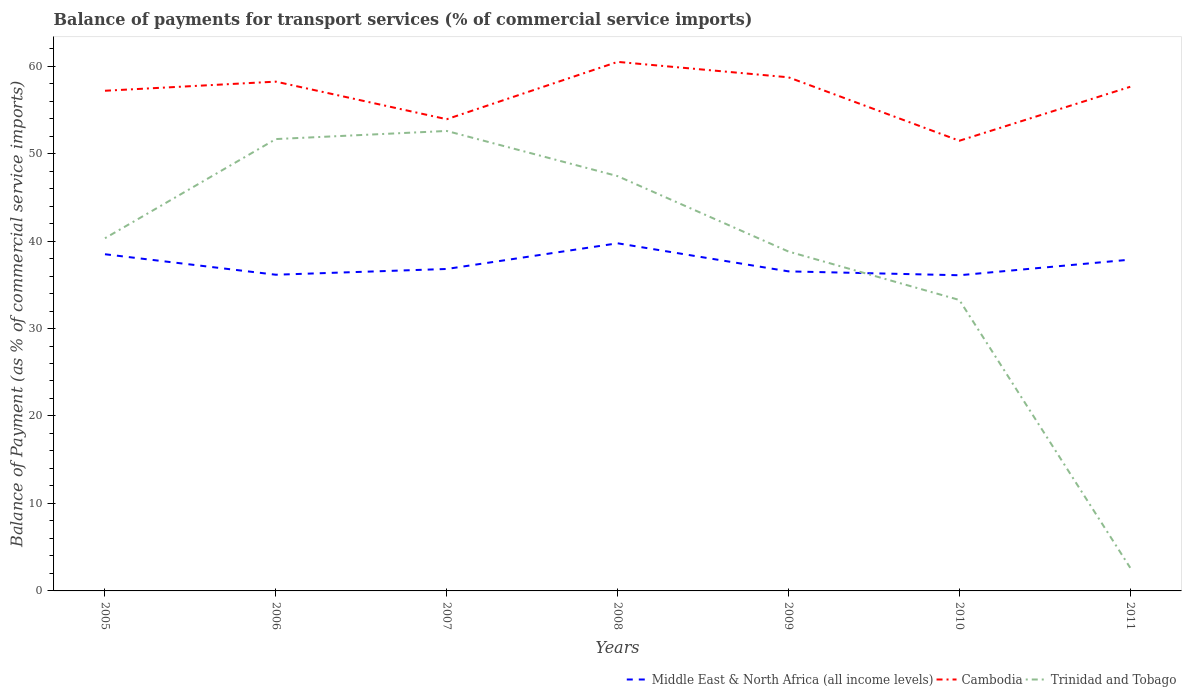How many different coloured lines are there?
Ensure brevity in your answer.  3. Does the line corresponding to Cambodia intersect with the line corresponding to Middle East & North Africa (all income levels)?
Provide a short and direct response. No. Across all years, what is the maximum balance of payments for transport services in Cambodia?
Ensure brevity in your answer.  51.47. In which year was the balance of payments for transport services in Trinidad and Tobago maximum?
Offer a terse response. 2011. What is the total balance of payments for transport services in Cambodia in the graph?
Give a very brief answer. -2.26. What is the difference between the highest and the second highest balance of payments for transport services in Middle East & North Africa (all income levels)?
Keep it short and to the point. 3.65. What is the difference between the highest and the lowest balance of payments for transport services in Cambodia?
Your response must be concise. 5. Is the balance of payments for transport services in Trinidad and Tobago strictly greater than the balance of payments for transport services in Middle East & North Africa (all income levels) over the years?
Offer a very short reply. No. How many lines are there?
Provide a succinct answer. 3. What is the difference between two consecutive major ticks on the Y-axis?
Provide a short and direct response. 10. Does the graph contain any zero values?
Provide a succinct answer. No. Does the graph contain grids?
Keep it short and to the point. No. Where does the legend appear in the graph?
Ensure brevity in your answer.  Bottom right. How many legend labels are there?
Provide a short and direct response. 3. What is the title of the graph?
Ensure brevity in your answer.  Balance of payments for transport services (% of commercial service imports). Does "Togo" appear as one of the legend labels in the graph?
Make the answer very short. No. What is the label or title of the Y-axis?
Offer a terse response. Balance of Payment (as % of commercial service imports). What is the Balance of Payment (as % of commercial service imports) in Middle East & North Africa (all income levels) in 2005?
Give a very brief answer. 38.49. What is the Balance of Payment (as % of commercial service imports) in Cambodia in 2005?
Provide a succinct answer. 57.18. What is the Balance of Payment (as % of commercial service imports) of Trinidad and Tobago in 2005?
Ensure brevity in your answer.  40.32. What is the Balance of Payment (as % of commercial service imports) of Middle East & North Africa (all income levels) in 2006?
Offer a very short reply. 36.15. What is the Balance of Payment (as % of commercial service imports) in Cambodia in 2006?
Make the answer very short. 58.22. What is the Balance of Payment (as % of commercial service imports) of Trinidad and Tobago in 2006?
Give a very brief answer. 51.66. What is the Balance of Payment (as % of commercial service imports) of Middle East & North Africa (all income levels) in 2007?
Your answer should be compact. 36.81. What is the Balance of Payment (as % of commercial service imports) of Cambodia in 2007?
Your answer should be compact. 53.93. What is the Balance of Payment (as % of commercial service imports) of Trinidad and Tobago in 2007?
Give a very brief answer. 52.58. What is the Balance of Payment (as % of commercial service imports) of Middle East & North Africa (all income levels) in 2008?
Your answer should be very brief. 39.74. What is the Balance of Payment (as % of commercial service imports) in Cambodia in 2008?
Keep it short and to the point. 60.48. What is the Balance of Payment (as % of commercial service imports) of Trinidad and Tobago in 2008?
Ensure brevity in your answer.  47.42. What is the Balance of Payment (as % of commercial service imports) of Middle East & North Africa (all income levels) in 2009?
Ensure brevity in your answer.  36.53. What is the Balance of Payment (as % of commercial service imports) in Cambodia in 2009?
Offer a terse response. 58.72. What is the Balance of Payment (as % of commercial service imports) of Trinidad and Tobago in 2009?
Keep it short and to the point. 38.8. What is the Balance of Payment (as % of commercial service imports) in Middle East & North Africa (all income levels) in 2010?
Offer a terse response. 36.09. What is the Balance of Payment (as % of commercial service imports) of Cambodia in 2010?
Your answer should be compact. 51.47. What is the Balance of Payment (as % of commercial service imports) of Trinidad and Tobago in 2010?
Your response must be concise. 33.26. What is the Balance of Payment (as % of commercial service imports) of Middle East & North Africa (all income levels) in 2011?
Your answer should be very brief. 37.87. What is the Balance of Payment (as % of commercial service imports) in Cambodia in 2011?
Offer a very short reply. 57.63. What is the Balance of Payment (as % of commercial service imports) in Trinidad and Tobago in 2011?
Offer a very short reply. 2.64. Across all years, what is the maximum Balance of Payment (as % of commercial service imports) in Middle East & North Africa (all income levels)?
Keep it short and to the point. 39.74. Across all years, what is the maximum Balance of Payment (as % of commercial service imports) in Cambodia?
Provide a short and direct response. 60.48. Across all years, what is the maximum Balance of Payment (as % of commercial service imports) of Trinidad and Tobago?
Offer a terse response. 52.58. Across all years, what is the minimum Balance of Payment (as % of commercial service imports) in Middle East & North Africa (all income levels)?
Offer a terse response. 36.09. Across all years, what is the minimum Balance of Payment (as % of commercial service imports) of Cambodia?
Your answer should be compact. 51.47. Across all years, what is the minimum Balance of Payment (as % of commercial service imports) of Trinidad and Tobago?
Your answer should be very brief. 2.64. What is the total Balance of Payment (as % of commercial service imports) in Middle East & North Africa (all income levels) in the graph?
Provide a short and direct response. 261.68. What is the total Balance of Payment (as % of commercial service imports) in Cambodia in the graph?
Give a very brief answer. 397.63. What is the total Balance of Payment (as % of commercial service imports) in Trinidad and Tobago in the graph?
Your response must be concise. 266.69. What is the difference between the Balance of Payment (as % of commercial service imports) in Middle East & North Africa (all income levels) in 2005 and that in 2006?
Offer a terse response. 2.34. What is the difference between the Balance of Payment (as % of commercial service imports) of Cambodia in 2005 and that in 2006?
Your response must be concise. -1.04. What is the difference between the Balance of Payment (as % of commercial service imports) in Trinidad and Tobago in 2005 and that in 2006?
Your answer should be very brief. -11.34. What is the difference between the Balance of Payment (as % of commercial service imports) in Middle East & North Africa (all income levels) in 2005 and that in 2007?
Keep it short and to the point. 1.68. What is the difference between the Balance of Payment (as % of commercial service imports) in Cambodia in 2005 and that in 2007?
Provide a short and direct response. 3.25. What is the difference between the Balance of Payment (as % of commercial service imports) of Trinidad and Tobago in 2005 and that in 2007?
Offer a very short reply. -12.26. What is the difference between the Balance of Payment (as % of commercial service imports) in Middle East & North Africa (all income levels) in 2005 and that in 2008?
Give a very brief answer. -1.25. What is the difference between the Balance of Payment (as % of commercial service imports) in Cambodia in 2005 and that in 2008?
Your answer should be very brief. -3.3. What is the difference between the Balance of Payment (as % of commercial service imports) of Trinidad and Tobago in 2005 and that in 2008?
Keep it short and to the point. -7.1. What is the difference between the Balance of Payment (as % of commercial service imports) of Middle East & North Africa (all income levels) in 2005 and that in 2009?
Your response must be concise. 1.96. What is the difference between the Balance of Payment (as % of commercial service imports) of Cambodia in 2005 and that in 2009?
Provide a succinct answer. -1.54. What is the difference between the Balance of Payment (as % of commercial service imports) in Trinidad and Tobago in 2005 and that in 2009?
Your response must be concise. 1.52. What is the difference between the Balance of Payment (as % of commercial service imports) in Middle East & North Africa (all income levels) in 2005 and that in 2010?
Make the answer very short. 2.4. What is the difference between the Balance of Payment (as % of commercial service imports) in Cambodia in 2005 and that in 2010?
Provide a succinct answer. 5.72. What is the difference between the Balance of Payment (as % of commercial service imports) in Trinidad and Tobago in 2005 and that in 2010?
Ensure brevity in your answer.  7.06. What is the difference between the Balance of Payment (as % of commercial service imports) of Middle East & North Africa (all income levels) in 2005 and that in 2011?
Give a very brief answer. 0.62. What is the difference between the Balance of Payment (as % of commercial service imports) of Cambodia in 2005 and that in 2011?
Make the answer very short. -0.45. What is the difference between the Balance of Payment (as % of commercial service imports) in Trinidad and Tobago in 2005 and that in 2011?
Provide a succinct answer. 37.68. What is the difference between the Balance of Payment (as % of commercial service imports) of Middle East & North Africa (all income levels) in 2006 and that in 2007?
Ensure brevity in your answer.  -0.66. What is the difference between the Balance of Payment (as % of commercial service imports) of Cambodia in 2006 and that in 2007?
Your answer should be very brief. 4.3. What is the difference between the Balance of Payment (as % of commercial service imports) in Trinidad and Tobago in 2006 and that in 2007?
Your answer should be compact. -0.93. What is the difference between the Balance of Payment (as % of commercial service imports) of Middle East & North Africa (all income levels) in 2006 and that in 2008?
Provide a succinct answer. -3.6. What is the difference between the Balance of Payment (as % of commercial service imports) of Cambodia in 2006 and that in 2008?
Your answer should be compact. -2.26. What is the difference between the Balance of Payment (as % of commercial service imports) of Trinidad and Tobago in 2006 and that in 2008?
Your answer should be very brief. 4.24. What is the difference between the Balance of Payment (as % of commercial service imports) in Middle East & North Africa (all income levels) in 2006 and that in 2009?
Your answer should be compact. -0.38. What is the difference between the Balance of Payment (as % of commercial service imports) in Cambodia in 2006 and that in 2009?
Your answer should be very brief. -0.49. What is the difference between the Balance of Payment (as % of commercial service imports) in Trinidad and Tobago in 2006 and that in 2009?
Your answer should be compact. 12.86. What is the difference between the Balance of Payment (as % of commercial service imports) of Middle East & North Africa (all income levels) in 2006 and that in 2010?
Give a very brief answer. 0.06. What is the difference between the Balance of Payment (as % of commercial service imports) of Cambodia in 2006 and that in 2010?
Offer a very short reply. 6.76. What is the difference between the Balance of Payment (as % of commercial service imports) in Trinidad and Tobago in 2006 and that in 2010?
Give a very brief answer. 18.4. What is the difference between the Balance of Payment (as % of commercial service imports) of Middle East & North Africa (all income levels) in 2006 and that in 2011?
Offer a terse response. -1.73. What is the difference between the Balance of Payment (as % of commercial service imports) in Cambodia in 2006 and that in 2011?
Offer a terse response. 0.59. What is the difference between the Balance of Payment (as % of commercial service imports) of Trinidad and Tobago in 2006 and that in 2011?
Provide a short and direct response. 49.02. What is the difference between the Balance of Payment (as % of commercial service imports) in Middle East & North Africa (all income levels) in 2007 and that in 2008?
Offer a terse response. -2.94. What is the difference between the Balance of Payment (as % of commercial service imports) of Cambodia in 2007 and that in 2008?
Offer a terse response. -6.56. What is the difference between the Balance of Payment (as % of commercial service imports) in Trinidad and Tobago in 2007 and that in 2008?
Your answer should be very brief. 5.16. What is the difference between the Balance of Payment (as % of commercial service imports) in Middle East & North Africa (all income levels) in 2007 and that in 2009?
Make the answer very short. 0.27. What is the difference between the Balance of Payment (as % of commercial service imports) of Cambodia in 2007 and that in 2009?
Your answer should be compact. -4.79. What is the difference between the Balance of Payment (as % of commercial service imports) of Trinidad and Tobago in 2007 and that in 2009?
Provide a succinct answer. 13.79. What is the difference between the Balance of Payment (as % of commercial service imports) of Middle East & North Africa (all income levels) in 2007 and that in 2010?
Provide a succinct answer. 0.72. What is the difference between the Balance of Payment (as % of commercial service imports) in Cambodia in 2007 and that in 2010?
Provide a succinct answer. 2.46. What is the difference between the Balance of Payment (as % of commercial service imports) in Trinidad and Tobago in 2007 and that in 2010?
Provide a short and direct response. 19.32. What is the difference between the Balance of Payment (as % of commercial service imports) of Middle East & North Africa (all income levels) in 2007 and that in 2011?
Offer a terse response. -1.07. What is the difference between the Balance of Payment (as % of commercial service imports) in Cambodia in 2007 and that in 2011?
Provide a short and direct response. -3.71. What is the difference between the Balance of Payment (as % of commercial service imports) of Trinidad and Tobago in 2007 and that in 2011?
Your answer should be compact. 49.94. What is the difference between the Balance of Payment (as % of commercial service imports) of Middle East & North Africa (all income levels) in 2008 and that in 2009?
Offer a very short reply. 3.21. What is the difference between the Balance of Payment (as % of commercial service imports) in Cambodia in 2008 and that in 2009?
Offer a terse response. 1.76. What is the difference between the Balance of Payment (as % of commercial service imports) of Trinidad and Tobago in 2008 and that in 2009?
Provide a short and direct response. 8.62. What is the difference between the Balance of Payment (as % of commercial service imports) in Middle East & North Africa (all income levels) in 2008 and that in 2010?
Keep it short and to the point. 3.65. What is the difference between the Balance of Payment (as % of commercial service imports) of Cambodia in 2008 and that in 2010?
Your answer should be compact. 9.02. What is the difference between the Balance of Payment (as % of commercial service imports) of Trinidad and Tobago in 2008 and that in 2010?
Your response must be concise. 14.16. What is the difference between the Balance of Payment (as % of commercial service imports) of Middle East & North Africa (all income levels) in 2008 and that in 2011?
Ensure brevity in your answer.  1.87. What is the difference between the Balance of Payment (as % of commercial service imports) in Cambodia in 2008 and that in 2011?
Provide a short and direct response. 2.85. What is the difference between the Balance of Payment (as % of commercial service imports) in Trinidad and Tobago in 2008 and that in 2011?
Your answer should be very brief. 44.78. What is the difference between the Balance of Payment (as % of commercial service imports) in Middle East & North Africa (all income levels) in 2009 and that in 2010?
Make the answer very short. 0.44. What is the difference between the Balance of Payment (as % of commercial service imports) of Cambodia in 2009 and that in 2010?
Give a very brief answer. 7.25. What is the difference between the Balance of Payment (as % of commercial service imports) in Trinidad and Tobago in 2009 and that in 2010?
Provide a short and direct response. 5.54. What is the difference between the Balance of Payment (as % of commercial service imports) of Middle East & North Africa (all income levels) in 2009 and that in 2011?
Your answer should be compact. -1.34. What is the difference between the Balance of Payment (as % of commercial service imports) of Cambodia in 2009 and that in 2011?
Provide a short and direct response. 1.08. What is the difference between the Balance of Payment (as % of commercial service imports) in Trinidad and Tobago in 2009 and that in 2011?
Offer a very short reply. 36.16. What is the difference between the Balance of Payment (as % of commercial service imports) in Middle East & North Africa (all income levels) in 2010 and that in 2011?
Provide a succinct answer. -1.78. What is the difference between the Balance of Payment (as % of commercial service imports) of Cambodia in 2010 and that in 2011?
Your answer should be compact. -6.17. What is the difference between the Balance of Payment (as % of commercial service imports) in Trinidad and Tobago in 2010 and that in 2011?
Offer a very short reply. 30.62. What is the difference between the Balance of Payment (as % of commercial service imports) in Middle East & North Africa (all income levels) in 2005 and the Balance of Payment (as % of commercial service imports) in Cambodia in 2006?
Your answer should be compact. -19.73. What is the difference between the Balance of Payment (as % of commercial service imports) of Middle East & North Africa (all income levels) in 2005 and the Balance of Payment (as % of commercial service imports) of Trinidad and Tobago in 2006?
Make the answer very short. -13.17. What is the difference between the Balance of Payment (as % of commercial service imports) in Cambodia in 2005 and the Balance of Payment (as % of commercial service imports) in Trinidad and Tobago in 2006?
Your response must be concise. 5.52. What is the difference between the Balance of Payment (as % of commercial service imports) in Middle East & North Africa (all income levels) in 2005 and the Balance of Payment (as % of commercial service imports) in Cambodia in 2007?
Offer a terse response. -15.44. What is the difference between the Balance of Payment (as % of commercial service imports) in Middle East & North Africa (all income levels) in 2005 and the Balance of Payment (as % of commercial service imports) in Trinidad and Tobago in 2007?
Ensure brevity in your answer.  -14.09. What is the difference between the Balance of Payment (as % of commercial service imports) in Cambodia in 2005 and the Balance of Payment (as % of commercial service imports) in Trinidad and Tobago in 2007?
Your response must be concise. 4.6. What is the difference between the Balance of Payment (as % of commercial service imports) of Middle East & North Africa (all income levels) in 2005 and the Balance of Payment (as % of commercial service imports) of Cambodia in 2008?
Provide a succinct answer. -21.99. What is the difference between the Balance of Payment (as % of commercial service imports) in Middle East & North Africa (all income levels) in 2005 and the Balance of Payment (as % of commercial service imports) in Trinidad and Tobago in 2008?
Ensure brevity in your answer.  -8.93. What is the difference between the Balance of Payment (as % of commercial service imports) in Cambodia in 2005 and the Balance of Payment (as % of commercial service imports) in Trinidad and Tobago in 2008?
Ensure brevity in your answer.  9.76. What is the difference between the Balance of Payment (as % of commercial service imports) of Middle East & North Africa (all income levels) in 2005 and the Balance of Payment (as % of commercial service imports) of Cambodia in 2009?
Make the answer very short. -20.23. What is the difference between the Balance of Payment (as % of commercial service imports) of Middle East & North Africa (all income levels) in 2005 and the Balance of Payment (as % of commercial service imports) of Trinidad and Tobago in 2009?
Your answer should be very brief. -0.31. What is the difference between the Balance of Payment (as % of commercial service imports) of Cambodia in 2005 and the Balance of Payment (as % of commercial service imports) of Trinidad and Tobago in 2009?
Provide a short and direct response. 18.38. What is the difference between the Balance of Payment (as % of commercial service imports) of Middle East & North Africa (all income levels) in 2005 and the Balance of Payment (as % of commercial service imports) of Cambodia in 2010?
Offer a terse response. -12.98. What is the difference between the Balance of Payment (as % of commercial service imports) in Middle East & North Africa (all income levels) in 2005 and the Balance of Payment (as % of commercial service imports) in Trinidad and Tobago in 2010?
Your answer should be very brief. 5.23. What is the difference between the Balance of Payment (as % of commercial service imports) in Cambodia in 2005 and the Balance of Payment (as % of commercial service imports) in Trinidad and Tobago in 2010?
Your response must be concise. 23.92. What is the difference between the Balance of Payment (as % of commercial service imports) in Middle East & North Africa (all income levels) in 2005 and the Balance of Payment (as % of commercial service imports) in Cambodia in 2011?
Provide a short and direct response. -19.14. What is the difference between the Balance of Payment (as % of commercial service imports) in Middle East & North Africa (all income levels) in 2005 and the Balance of Payment (as % of commercial service imports) in Trinidad and Tobago in 2011?
Your answer should be very brief. 35.85. What is the difference between the Balance of Payment (as % of commercial service imports) of Cambodia in 2005 and the Balance of Payment (as % of commercial service imports) of Trinidad and Tobago in 2011?
Provide a succinct answer. 54.54. What is the difference between the Balance of Payment (as % of commercial service imports) of Middle East & North Africa (all income levels) in 2006 and the Balance of Payment (as % of commercial service imports) of Cambodia in 2007?
Your answer should be compact. -17.78. What is the difference between the Balance of Payment (as % of commercial service imports) of Middle East & North Africa (all income levels) in 2006 and the Balance of Payment (as % of commercial service imports) of Trinidad and Tobago in 2007?
Offer a terse response. -16.44. What is the difference between the Balance of Payment (as % of commercial service imports) in Cambodia in 2006 and the Balance of Payment (as % of commercial service imports) in Trinidad and Tobago in 2007?
Ensure brevity in your answer.  5.64. What is the difference between the Balance of Payment (as % of commercial service imports) of Middle East & North Africa (all income levels) in 2006 and the Balance of Payment (as % of commercial service imports) of Cambodia in 2008?
Your answer should be compact. -24.33. What is the difference between the Balance of Payment (as % of commercial service imports) of Middle East & North Africa (all income levels) in 2006 and the Balance of Payment (as % of commercial service imports) of Trinidad and Tobago in 2008?
Your answer should be very brief. -11.27. What is the difference between the Balance of Payment (as % of commercial service imports) of Cambodia in 2006 and the Balance of Payment (as % of commercial service imports) of Trinidad and Tobago in 2008?
Offer a very short reply. 10.8. What is the difference between the Balance of Payment (as % of commercial service imports) in Middle East & North Africa (all income levels) in 2006 and the Balance of Payment (as % of commercial service imports) in Cambodia in 2009?
Your answer should be compact. -22.57. What is the difference between the Balance of Payment (as % of commercial service imports) of Middle East & North Africa (all income levels) in 2006 and the Balance of Payment (as % of commercial service imports) of Trinidad and Tobago in 2009?
Provide a short and direct response. -2.65. What is the difference between the Balance of Payment (as % of commercial service imports) of Cambodia in 2006 and the Balance of Payment (as % of commercial service imports) of Trinidad and Tobago in 2009?
Keep it short and to the point. 19.43. What is the difference between the Balance of Payment (as % of commercial service imports) in Middle East & North Africa (all income levels) in 2006 and the Balance of Payment (as % of commercial service imports) in Cambodia in 2010?
Your answer should be very brief. -15.32. What is the difference between the Balance of Payment (as % of commercial service imports) of Middle East & North Africa (all income levels) in 2006 and the Balance of Payment (as % of commercial service imports) of Trinidad and Tobago in 2010?
Give a very brief answer. 2.89. What is the difference between the Balance of Payment (as % of commercial service imports) in Cambodia in 2006 and the Balance of Payment (as % of commercial service imports) in Trinidad and Tobago in 2010?
Your response must be concise. 24.96. What is the difference between the Balance of Payment (as % of commercial service imports) in Middle East & North Africa (all income levels) in 2006 and the Balance of Payment (as % of commercial service imports) in Cambodia in 2011?
Offer a terse response. -21.49. What is the difference between the Balance of Payment (as % of commercial service imports) in Middle East & North Africa (all income levels) in 2006 and the Balance of Payment (as % of commercial service imports) in Trinidad and Tobago in 2011?
Give a very brief answer. 33.51. What is the difference between the Balance of Payment (as % of commercial service imports) of Cambodia in 2006 and the Balance of Payment (as % of commercial service imports) of Trinidad and Tobago in 2011?
Offer a terse response. 55.58. What is the difference between the Balance of Payment (as % of commercial service imports) in Middle East & North Africa (all income levels) in 2007 and the Balance of Payment (as % of commercial service imports) in Cambodia in 2008?
Provide a succinct answer. -23.68. What is the difference between the Balance of Payment (as % of commercial service imports) in Middle East & North Africa (all income levels) in 2007 and the Balance of Payment (as % of commercial service imports) in Trinidad and Tobago in 2008?
Make the answer very short. -10.61. What is the difference between the Balance of Payment (as % of commercial service imports) in Cambodia in 2007 and the Balance of Payment (as % of commercial service imports) in Trinidad and Tobago in 2008?
Keep it short and to the point. 6.51. What is the difference between the Balance of Payment (as % of commercial service imports) of Middle East & North Africa (all income levels) in 2007 and the Balance of Payment (as % of commercial service imports) of Cambodia in 2009?
Your answer should be compact. -21.91. What is the difference between the Balance of Payment (as % of commercial service imports) in Middle East & North Africa (all income levels) in 2007 and the Balance of Payment (as % of commercial service imports) in Trinidad and Tobago in 2009?
Your response must be concise. -1.99. What is the difference between the Balance of Payment (as % of commercial service imports) in Cambodia in 2007 and the Balance of Payment (as % of commercial service imports) in Trinidad and Tobago in 2009?
Offer a terse response. 15.13. What is the difference between the Balance of Payment (as % of commercial service imports) of Middle East & North Africa (all income levels) in 2007 and the Balance of Payment (as % of commercial service imports) of Cambodia in 2010?
Keep it short and to the point. -14.66. What is the difference between the Balance of Payment (as % of commercial service imports) in Middle East & North Africa (all income levels) in 2007 and the Balance of Payment (as % of commercial service imports) in Trinidad and Tobago in 2010?
Offer a very short reply. 3.54. What is the difference between the Balance of Payment (as % of commercial service imports) of Cambodia in 2007 and the Balance of Payment (as % of commercial service imports) of Trinidad and Tobago in 2010?
Offer a very short reply. 20.67. What is the difference between the Balance of Payment (as % of commercial service imports) in Middle East & North Africa (all income levels) in 2007 and the Balance of Payment (as % of commercial service imports) in Cambodia in 2011?
Your answer should be very brief. -20.83. What is the difference between the Balance of Payment (as % of commercial service imports) of Middle East & North Africa (all income levels) in 2007 and the Balance of Payment (as % of commercial service imports) of Trinidad and Tobago in 2011?
Keep it short and to the point. 34.16. What is the difference between the Balance of Payment (as % of commercial service imports) in Cambodia in 2007 and the Balance of Payment (as % of commercial service imports) in Trinidad and Tobago in 2011?
Offer a terse response. 51.28. What is the difference between the Balance of Payment (as % of commercial service imports) in Middle East & North Africa (all income levels) in 2008 and the Balance of Payment (as % of commercial service imports) in Cambodia in 2009?
Your answer should be compact. -18.98. What is the difference between the Balance of Payment (as % of commercial service imports) of Middle East & North Africa (all income levels) in 2008 and the Balance of Payment (as % of commercial service imports) of Trinidad and Tobago in 2009?
Your response must be concise. 0.94. What is the difference between the Balance of Payment (as % of commercial service imports) of Cambodia in 2008 and the Balance of Payment (as % of commercial service imports) of Trinidad and Tobago in 2009?
Provide a short and direct response. 21.68. What is the difference between the Balance of Payment (as % of commercial service imports) in Middle East & North Africa (all income levels) in 2008 and the Balance of Payment (as % of commercial service imports) in Cambodia in 2010?
Give a very brief answer. -11.72. What is the difference between the Balance of Payment (as % of commercial service imports) of Middle East & North Africa (all income levels) in 2008 and the Balance of Payment (as % of commercial service imports) of Trinidad and Tobago in 2010?
Your answer should be very brief. 6.48. What is the difference between the Balance of Payment (as % of commercial service imports) in Cambodia in 2008 and the Balance of Payment (as % of commercial service imports) in Trinidad and Tobago in 2010?
Your answer should be compact. 27.22. What is the difference between the Balance of Payment (as % of commercial service imports) in Middle East & North Africa (all income levels) in 2008 and the Balance of Payment (as % of commercial service imports) in Cambodia in 2011?
Your answer should be compact. -17.89. What is the difference between the Balance of Payment (as % of commercial service imports) in Middle East & North Africa (all income levels) in 2008 and the Balance of Payment (as % of commercial service imports) in Trinidad and Tobago in 2011?
Ensure brevity in your answer.  37.1. What is the difference between the Balance of Payment (as % of commercial service imports) in Cambodia in 2008 and the Balance of Payment (as % of commercial service imports) in Trinidad and Tobago in 2011?
Your response must be concise. 57.84. What is the difference between the Balance of Payment (as % of commercial service imports) in Middle East & North Africa (all income levels) in 2009 and the Balance of Payment (as % of commercial service imports) in Cambodia in 2010?
Keep it short and to the point. -14.93. What is the difference between the Balance of Payment (as % of commercial service imports) of Middle East & North Africa (all income levels) in 2009 and the Balance of Payment (as % of commercial service imports) of Trinidad and Tobago in 2010?
Your response must be concise. 3.27. What is the difference between the Balance of Payment (as % of commercial service imports) in Cambodia in 2009 and the Balance of Payment (as % of commercial service imports) in Trinidad and Tobago in 2010?
Offer a terse response. 25.46. What is the difference between the Balance of Payment (as % of commercial service imports) in Middle East & North Africa (all income levels) in 2009 and the Balance of Payment (as % of commercial service imports) in Cambodia in 2011?
Provide a short and direct response. -21.1. What is the difference between the Balance of Payment (as % of commercial service imports) of Middle East & North Africa (all income levels) in 2009 and the Balance of Payment (as % of commercial service imports) of Trinidad and Tobago in 2011?
Your answer should be very brief. 33.89. What is the difference between the Balance of Payment (as % of commercial service imports) in Cambodia in 2009 and the Balance of Payment (as % of commercial service imports) in Trinidad and Tobago in 2011?
Your answer should be very brief. 56.08. What is the difference between the Balance of Payment (as % of commercial service imports) of Middle East & North Africa (all income levels) in 2010 and the Balance of Payment (as % of commercial service imports) of Cambodia in 2011?
Keep it short and to the point. -21.55. What is the difference between the Balance of Payment (as % of commercial service imports) of Middle East & North Africa (all income levels) in 2010 and the Balance of Payment (as % of commercial service imports) of Trinidad and Tobago in 2011?
Make the answer very short. 33.45. What is the difference between the Balance of Payment (as % of commercial service imports) in Cambodia in 2010 and the Balance of Payment (as % of commercial service imports) in Trinidad and Tobago in 2011?
Your response must be concise. 48.82. What is the average Balance of Payment (as % of commercial service imports) of Middle East & North Africa (all income levels) per year?
Offer a very short reply. 37.38. What is the average Balance of Payment (as % of commercial service imports) in Cambodia per year?
Keep it short and to the point. 56.8. What is the average Balance of Payment (as % of commercial service imports) in Trinidad and Tobago per year?
Keep it short and to the point. 38.1. In the year 2005, what is the difference between the Balance of Payment (as % of commercial service imports) of Middle East & North Africa (all income levels) and Balance of Payment (as % of commercial service imports) of Cambodia?
Offer a terse response. -18.69. In the year 2005, what is the difference between the Balance of Payment (as % of commercial service imports) of Middle East & North Africa (all income levels) and Balance of Payment (as % of commercial service imports) of Trinidad and Tobago?
Provide a short and direct response. -1.83. In the year 2005, what is the difference between the Balance of Payment (as % of commercial service imports) of Cambodia and Balance of Payment (as % of commercial service imports) of Trinidad and Tobago?
Provide a succinct answer. 16.86. In the year 2006, what is the difference between the Balance of Payment (as % of commercial service imports) in Middle East & North Africa (all income levels) and Balance of Payment (as % of commercial service imports) in Cambodia?
Offer a very short reply. -22.08. In the year 2006, what is the difference between the Balance of Payment (as % of commercial service imports) in Middle East & North Africa (all income levels) and Balance of Payment (as % of commercial service imports) in Trinidad and Tobago?
Provide a short and direct response. -15.51. In the year 2006, what is the difference between the Balance of Payment (as % of commercial service imports) in Cambodia and Balance of Payment (as % of commercial service imports) in Trinidad and Tobago?
Your answer should be very brief. 6.57. In the year 2007, what is the difference between the Balance of Payment (as % of commercial service imports) in Middle East & North Africa (all income levels) and Balance of Payment (as % of commercial service imports) in Cambodia?
Keep it short and to the point. -17.12. In the year 2007, what is the difference between the Balance of Payment (as % of commercial service imports) in Middle East & North Africa (all income levels) and Balance of Payment (as % of commercial service imports) in Trinidad and Tobago?
Your answer should be very brief. -15.78. In the year 2007, what is the difference between the Balance of Payment (as % of commercial service imports) in Cambodia and Balance of Payment (as % of commercial service imports) in Trinidad and Tobago?
Your answer should be compact. 1.34. In the year 2008, what is the difference between the Balance of Payment (as % of commercial service imports) of Middle East & North Africa (all income levels) and Balance of Payment (as % of commercial service imports) of Cambodia?
Ensure brevity in your answer.  -20.74. In the year 2008, what is the difference between the Balance of Payment (as % of commercial service imports) in Middle East & North Africa (all income levels) and Balance of Payment (as % of commercial service imports) in Trinidad and Tobago?
Keep it short and to the point. -7.68. In the year 2008, what is the difference between the Balance of Payment (as % of commercial service imports) of Cambodia and Balance of Payment (as % of commercial service imports) of Trinidad and Tobago?
Make the answer very short. 13.06. In the year 2009, what is the difference between the Balance of Payment (as % of commercial service imports) of Middle East & North Africa (all income levels) and Balance of Payment (as % of commercial service imports) of Cambodia?
Give a very brief answer. -22.19. In the year 2009, what is the difference between the Balance of Payment (as % of commercial service imports) in Middle East & North Africa (all income levels) and Balance of Payment (as % of commercial service imports) in Trinidad and Tobago?
Keep it short and to the point. -2.27. In the year 2009, what is the difference between the Balance of Payment (as % of commercial service imports) of Cambodia and Balance of Payment (as % of commercial service imports) of Trinidad and Tobago?
Your answer should be very brief. 19.92. In the year 2010, what is the difference between the Balance of Payment (as % of commercial service imports) of Middle East & North Africa (all income levels) and Balance of Payment (as % of commercial service imports) of Cambodia?
Your answer should be very brief. -15.38. In the year 2010, what is the difference between the Balance of Payment (as % of commercial service imports) of Middle East & North Africa (all income levels) and Balance of Payment (as % of commercial service imports) of Trinidad and Tobago?
Your response must be concise. 2.83. In the year 2010, what is the difference between the Balance of Payment (as % of commercial service imports) of Cambodia and Balance of Payment (as % of commercial service imports) of Trinidad and Tobago?
Your response must be concise. 18.2. In the year 2011, what is the difference between the Balance of Payment (as % of commercial service imports) of Middle East & North Africa (all income levels) and Balance of Payment (as % of commercial service imports) of Cambodia?
Provide a succinct answer. -19.76. In the year 2011, what is the difference between the Balance of Payment (as % of commercial service imports) in Middle East & North Africa (all income levels) and Balance of Payment (as % of commercial service imports) in Trinidad and Tobago?
Offer a very short reply. 35.23. In the year 2011, what is the difference between the Balance of Payment (as % of commercial service imports) in Cambodia and Balance of Payment (as % of commercial service imports) in Trinidad and Tobago?
Your response must be concise. 54.99. What is the ratio of the Balance of Payment (as % of commercial service imports) in Middle East & North Africa (all income levels) in 2005 to that in 2006?
Provide a short and direct response. 1.06. What is the ratio of the Balance of Payment (as % of commercial service imports) in Cambodia in 2005 to that in 2006?
Make the answer very short. 0.98. What is the ratio of the Balance of Payment (as % of commercial service imports) of Trinidad and Tobago in 2005 to that in 2006?
Your answer should be very brief. 0.78. What is the ratio of the Balance of Payment (as % of commercial service imports) in Middle East & North Africa (all income levels) in 2005 to that in 2007?
Ensure brevity in your answer.  1.05. What is the ratio of the Balance of Payment (as % of commercial service imports) in Cambodia in 2005 to that in 2007?
Offer a terse response. 1.06. What is the ratio of the Balance of Payment (as % of commercial service imports) in Trinidad and Tobago in 2005 to that in 2007?
Your answer should be compact. 0.77. What is the ratio of the Balance of Payment (as % of commercial service imports) of Middle East & North Africa (all income levels) in 2005 to that in 2008?
Give a very brief answer. 0.97. What is the ratio of the Balance of Payment (as % of commercial service imports) in Cambodia in 2005 to that in 2008?
Provide a succinct answer. 0.95. What is the ratio of the Balance of Payment (as % of commercial service imports) in Trinidad and Tobago in 2005 to that in 2008?
Your answer should be very brief. 0.85. What is the ratio of the Balance of Payment (as % of commercial service imports) of Middle East & North Africa (all income levels) in 2005 to that in 2009?
Provide a succinct answer. 1.05. What is the ratio of the Balance of Payment (as % of commercial service imports) in Cambodia in 2005 to that in 2009?
Your answer should be compact. 0.97. What is the ratio of the Balance of Payment (as % of commercial service imports) in Trinidad and Tobago in 2005 to that in 2009?
Give a very brief answer. 1.04. What is the ratio of the Balance of Payment (as % of commercial service imports) of Middle East & North Africa (all income levels) in 2005 to that in 2010?
Your answer should be very brief. 1.07. What is the ratio of the Balance of Payment (as % of commercial service imports) of Cambodia in 2005 to that in 2010?
Offer a very short reply. 1.11. What is the ratio of the Balance of Payment (as % of commercial service imports) of Trinidad and Tobago in 2005 to that in 2010?
Give a very brief answer. 1.21. What is the ratio of the Balance of Payment (as % of commercial service imports) in Middle East & North Africa (all income levels) in 2005 to that in 2011?
Offer a very short reply. 1.02. What is the ratio of the Balance of Payment (as % of commercial service imports) in Cambodia in 2005 to that in 2011?
Ensure brevity in your answer.  0.99. What is the ratio of the Balance of Payment (as % of commercial service imports) of Trinidad and Tobago in 2005 to that in 2011?
Provide a short and direct response. 15.26. What is the ratio of the Balance of Payment (as % of commercial service imports) in Middle East & North Africa (all income levels) in 2006 to that in 2007?
Your answer should be very brief. 0.98. What is the ratio of the Balance of Payment (as % of commercial service imports) in Cambodia in 2006 to that in 2007?
Provide a succinct answer. 1.08. What is the ratio of the Balance of Payment (as % of commercial service imports) in Trinidad and Tobago in 2006 to that in 2007?
Provide a short and direct response. 0.98. What is the ratio of the Balance of Payment (as % of commercial service imports) in Middle East & North Africa (all income levels) in 2006 to that in 2008?
Provide a succinct answer. 0.91. What is the ratio of the Balance of Payment (as % of commercial service imports) in Cambodia in 2006 to that in 2008?
Ensure brevity in your answer.  0.96. What is the ratio of the Balance of Payment (as % of commercial service imports) of Trinidad and Tobago in 2006 to that in 2008?
Give a very brief answer. 1.09. What is the ratio of the Balance of Payment (as % of commercial service imports) in Middle East & North Africa (all income levels) in 2006 to that in 2009?
Your response must be concise. 0.99. What is the ratio of the Balance of Payment (as % of commercial service imports) in Trinidad and Tobago in 2006 to that in 2009?
Your answer should be very brief. 1.33. What is the ratio of the Balance of Payment (as % of commercial service imports) in Cambodia in 2006 to that in 2010?
Make the answer very short. 1.13. What is the ratio of the Balance of Payment (as % of commercial service imports) in Trinidad and Tobago in 2006 to that in 2010?
Provide a succinct answer. 1.55. What is the ratio of the Balance of Payment (as % of commercial service imports) of Middle East & North Africa (all income levels) in 2006 to that in 2011?
Your answer should be very brief. 0.95. What is the ratio of the Balance of Payment (as % of commercial service imports) of Cambodia in 2006 to that in 2011?
Your response must be concise. 1.01. What is the ratio of the Balance of Payment (as % of commercial service imports) in Trinidad and Tobago in 2006 to that in 2011?
Provide a succinct answer. 19.55. What is the ratio of the Balance of Payment (as % of commercial service imports) in Middle East & North Africa (all income levels) in 2007 to that in 2008?
Your response must be concise. 0.93. What is the ratio of the Balance of Payment (as % of commercial service imports) in Cambodia in 2007 to that in 2008?
Ensure brevity in your answer.  0.89. What is the ratio of the Balance of Payment (as % of commercial service imports) in Trinidad and Tobago in 2007 to that in 2008?
Offer a very short reply. 1.11. What is the ratio of the Balance of Payment (as % of commercial service imports) in Middle East & North Africa (all income levels) in 2007 to that in 2009?
Offer a very short reply. 1.01. What is the ratio of the Balance of Payment (as % of commercial service imports) of Cambodia in 2007 to that in 2009?
Provide a succinct answer. 0.92. What is the ratio of the Balance of Payment (as % of commercial service imports) of Trinidad and Tobago in 2007 to that in 2009?
Your answer should be compact. 1.36. What is the ratio of the Balance of Payment (as % of commercial service imports) of Middle East & North Africa (all income levels) in 2007 to that in 2010?
Your response must be concise. 1.02. What is the ratio of the Balance of Payment (as % of commercial service imports) in Cambodia in 2007 to that in 2010?
Ensure brevity in your answer.  1.05. What is the ratio of the Balance of Payment (as % of commercial service imports) of Trinidad and Tobago in 2007 to that in 2010?
Your response must be concise. 1.58. What is the ratio of the Balance of Payment (as % of commercial service imports) in Middle East & North Africa (all income levels) in 2007 to that in 2011?
Offer a terse response. 0.97. What is the ratio of the Balance of Payment (as % of commercial service imports) in Cambodia in 2007 to that in 2011?
Give a very brief answer. 0.94. What is the ratio of the Balance of Payment (as % of commercial service imports) of Trinidad and Tobago in 2007 to that in 2011?
Provide a succinct answer. 19.9. What is the ratio of the Balance of Payment (as % of commercial service imports) of Middle East & North Africa (all income levels) in 2008 to that in 2009?
Provide a short and direct response. 1.09. What is the ratio of the Balance of Payment (as % of commercial service imports) in Cambodia in 2008 to that in 2009?
Keep it short and to the point. 1.03. What is the ratio of the Balance of Payment (as % of commercial service imports) in Trinidad and Tobago in 2008 to that in 2009?
Keep it short and to the point. 1.22. What is the ratio of the Balance of Payment (as % of commercial service imports) of Middle East & North Africa (all income levels) in 2008 to that in 2010?
Offer a terse response. 1.1. What is the ratio of the Balance of Payment (as % of commercial service imports) of Cambodia in 2008 to that in 2010?
Provide a succinct answer. 1.18. What is the ratio of the Balance of Payment (as % of commercial service imports) of Trinidad and Tobago in 2008 to that in 2010?
Offer a very short reply. 1.43. What is the ratio of the Balance of Payment (as % of commercial service imports) of Middle East & North Africa (all income levels) in 2008 to that in 2011?
Your response must be concise. 1.05. What is the ratio of the Balance of Payment (as % of commercial service imports) of Cambodia in 2008 to that in 2011?
Make the answer very short. 1.05. What is the ratio of the Balance of Payment (as % of commercial service imports) in Trinidad and Tobago in 2008 to that in 2011?
Keep it short and to the point. 17.95. What is the ratio of the Balance of Payment (as % of commercial service imports) in Middle East & North Africa (all income levels) in 2009 to that in 2010?
Your answer should be compact. 1.01. What is the ratio of the Balance of Payment (as % of commercial service imports) of Cambodia in 2009 to that in 2010?
Make the answer very short. 1.14. What is the ratio of the Balance of Payment (as % of commercial service imports) in Trinidad and Tobago in 2009 to that in 2010?
Offer a very short reply. 1.17. What is the ratio of the Balance of Payment (as % of commercial service imports) of Middle East & North Africa (all income levels) in 2009 to that in 2011?
Provide a short and direct response. 0.96. What is the ratio of the Balance of Payment (as % of commercial service imports) of Cambodia in 2009 to that in 2011?
Keep it short and to the point. 1.02. What is the ratio of the Balance of Payment (as % of commercial service imports) of Trinidad and Tobago in 2009 to that in 2011?
Provide a succinct answer. 14.68. What is the ratio of the Balance of Payment (as % of commercial service imports) in Middle East & North Africa (all income levels) in 2010 to that in 2011?
Offer a very short reply. 0.95. What is the ratio of the Balance of Payment (as % of commercial service imports) of Cambodia in 2010 to that in 2011?
Make the answer very short. 0.89. What is the ratio of the Balance of Payment (as % of commercial service imports) of Trinidad and Tobago in 2010 to that in 2011?
Provide a succinct answer. 12.59. What is the difference between the highest and the second highest Balance of Payment (as % of commercial service imports) in Middle East & North Africa (all income levels)?
Provide a short and direct response. 1.25. What is the difference between the highest and the second highest Balance of Payment (as % of commercial service imports) of Cambodia?
Provide a succinct answer. 1.76. What is the difference between the highest and the second highest Balance of Payment (as % of commercial service imports) of Trinidad and Tobago?
Make the answer very short. 0.93. What is the difference between the highest and the lowest Balance of Payment (as % of commercial service imports) in Middle East & North Africa (all income levels)?
Give a very brief answer. 3.65. What is the difference between the highest and the lowest Balance of Payment (as % of commercial service imports) of Cambodia?
Ensure brevity in your answer.  9.02. What is the difference between the highest and the lowest Balance of Payment (as % of commercial service imports) of Trinidad and Tobago?
Provide a short and direct response. 49.94. 